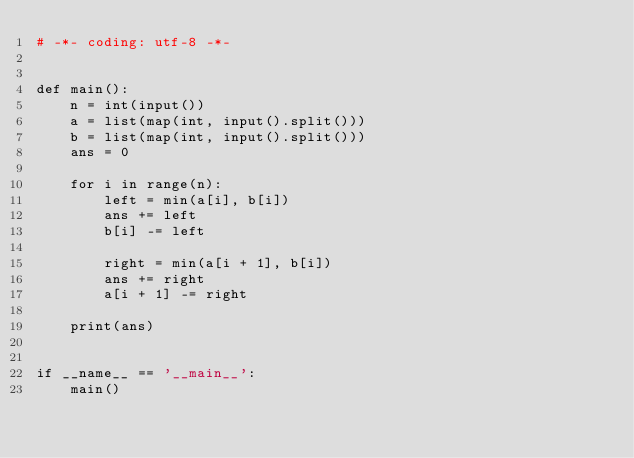Convert code to text. <code><loc_0><loc_0><loc_500><loc_500><_Python_># -*- coding: utf-8 -*-


def main():
    n = int(input())
    a = list(map(int, input().split()))
    b = list(map(int, input().split()))
    ans = 0

    for i in range(n):
        left = min(a[i], b[i])
        ans += left
        b[i] -= left

        right = min(a[i + 1], b[i])
        ans += right
        a[i + 1] -= right

    print(ans)


if __name__ == '__main__':
    main()
</code> 